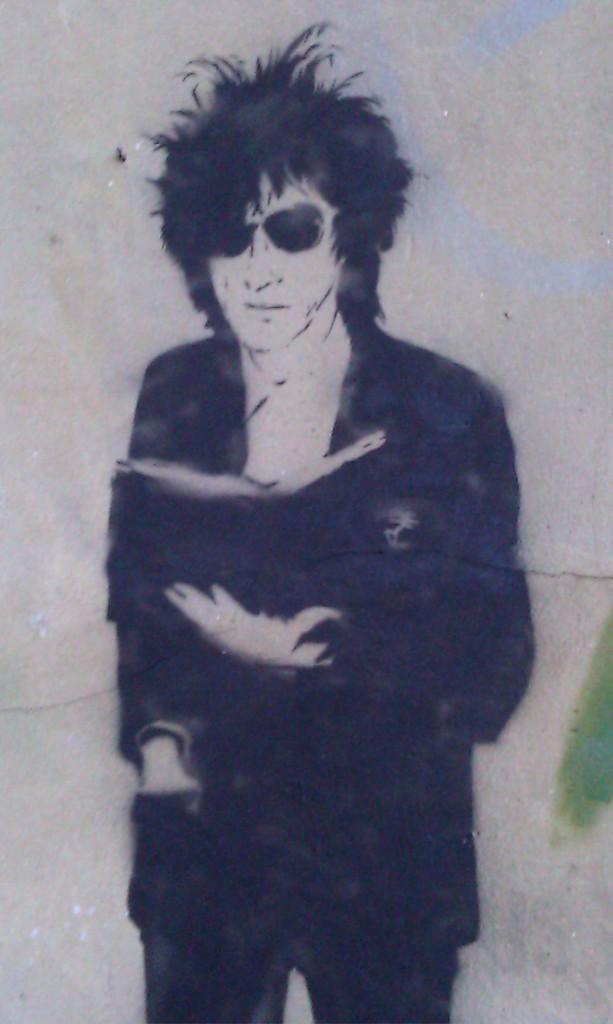Describe this image in one or two sentences. This is a painting. In this painting we can see there is a person in a black colored dress holding a book. And the background is gray in color. 